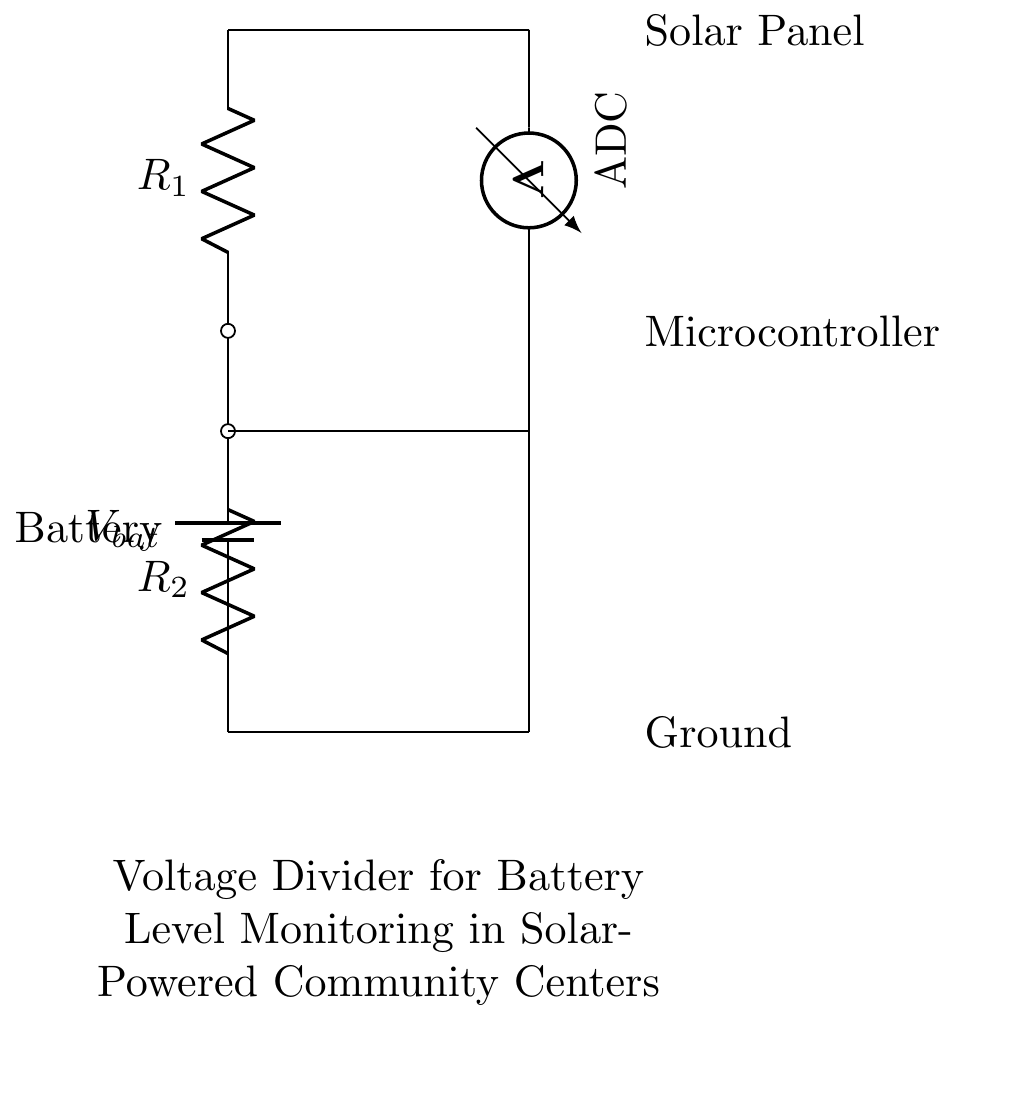What is the voltage source in this circuit? The voltage source is represented by the battery symbol labeled V bat; it is the component that provides electrical energy to the circuit.
Answer: V bat What components are in series in the voltage divider? The resistors R 1 and R 2 are in series; they are connected one after the other in the circuit, forming a single path for the current.
Answer: R 1 and R 2 What does the voltmeter measure in this circuit? The voltmeter is used to measure the voltage across R 2, which is crucial for monitoring the battery level; it indicates the potential difference at that point in the circuit.
Answer: Voltage across R 2 What is the purpose of using a voltage divider in this circuit? The purpose of the voltage divider is to reduce the voltage from the battery to a lower level that can be safely measured by the microcontroller; it helps in monitoring battery levels without overloading the components.
Answer: Monitoring battery levels How does the voltage divider output relate to the resistance values? The output voltage (V out) across R 2 can be calculated using the formula V out = V bat * (R 2 / (R 1 + R 2)); this shows how the output voltage changes with different resistor values, affecting the voltage measurement.
Answer: V out = V bat * (R 2 / (R 1 + R 2)) 